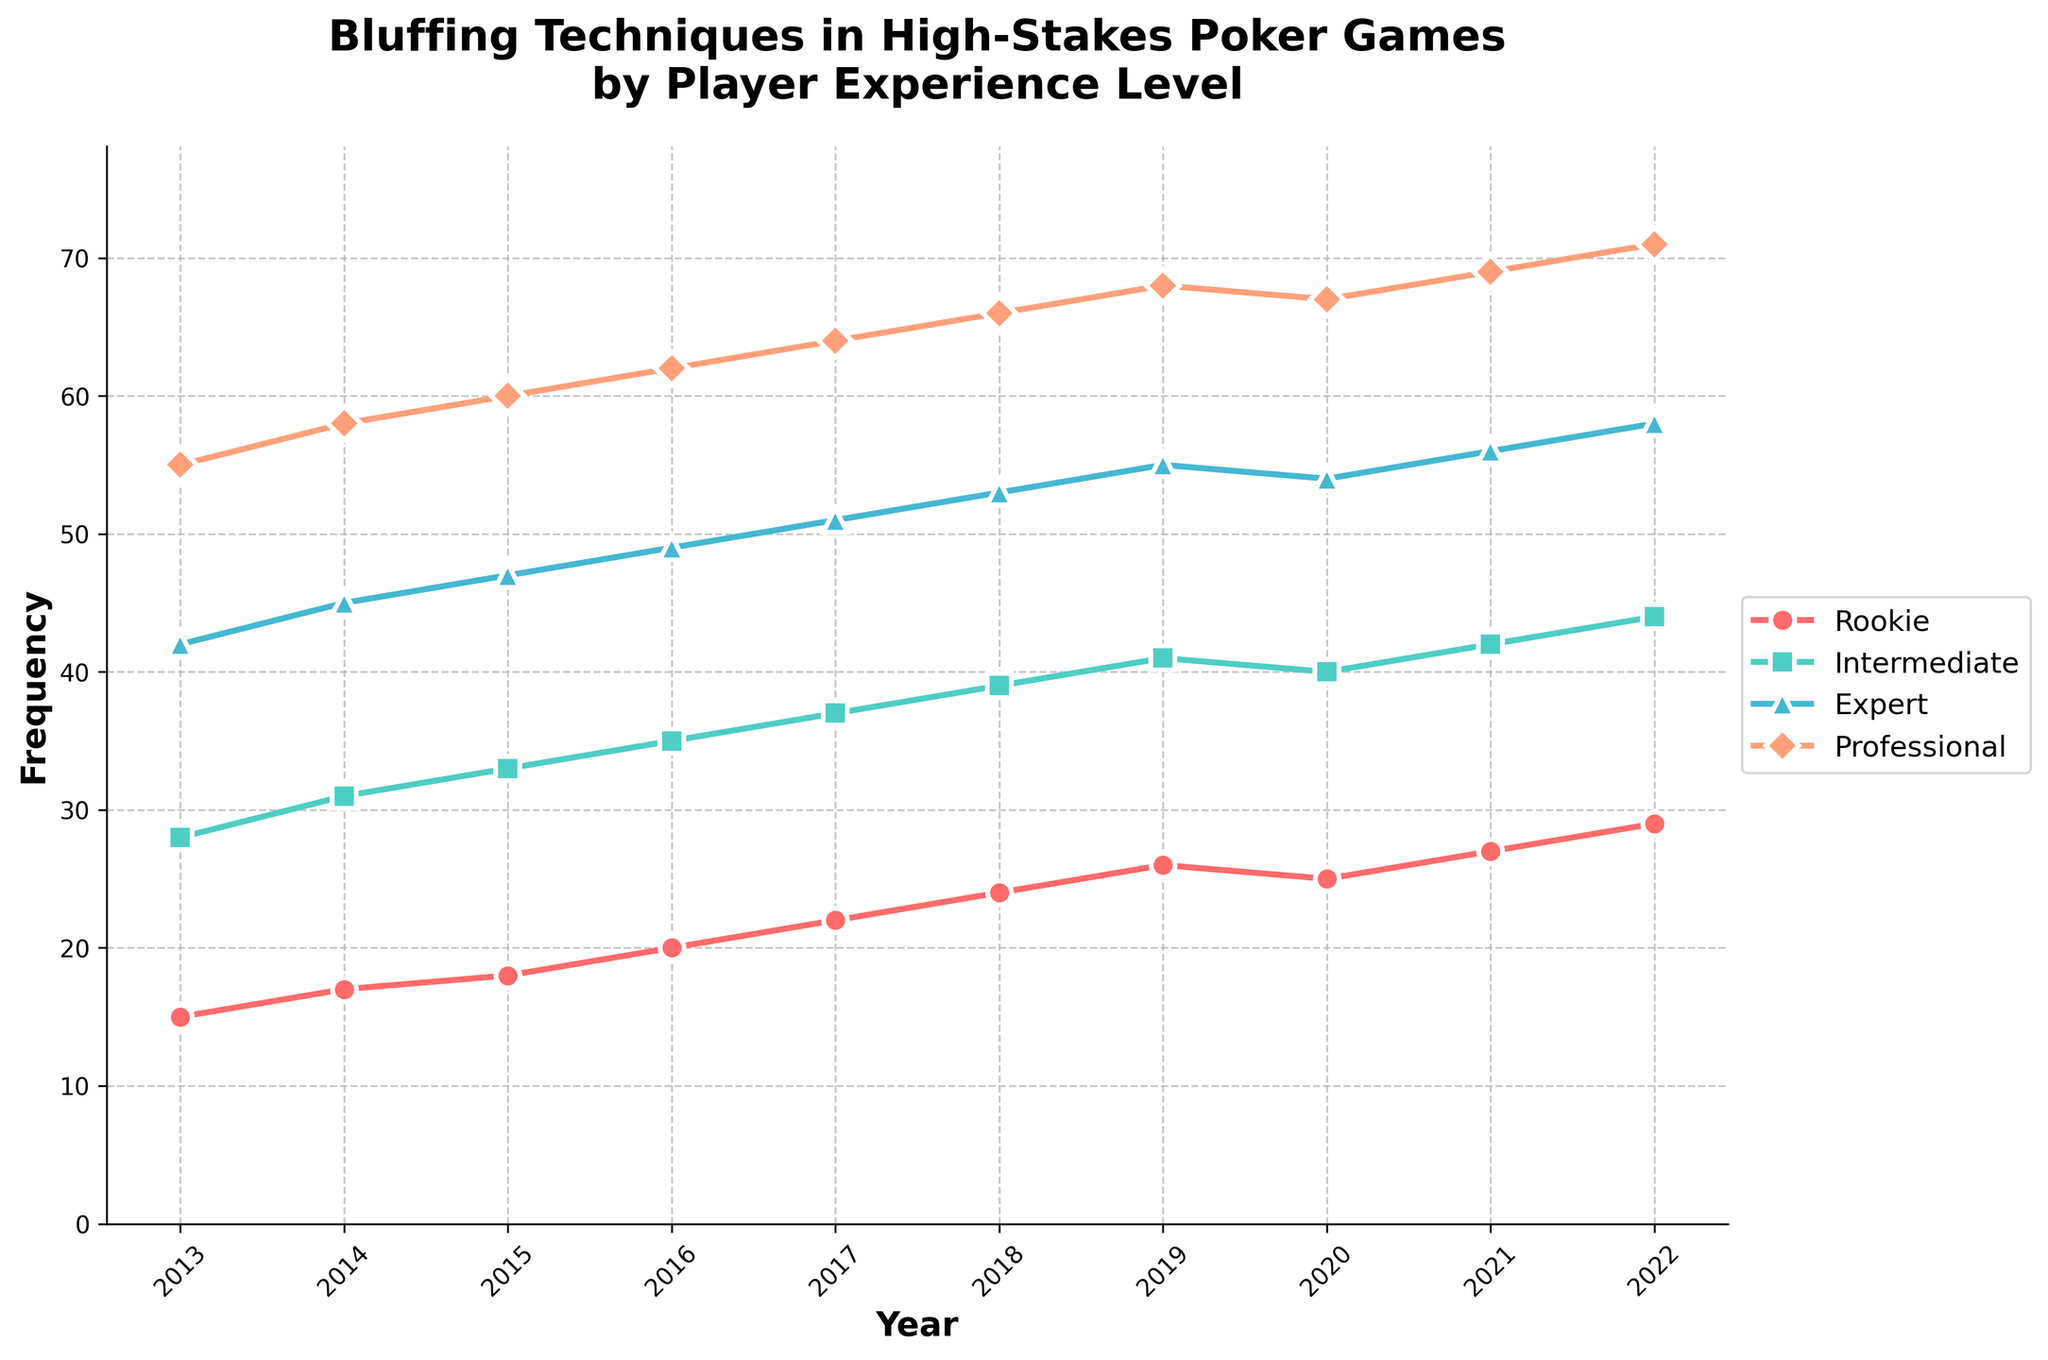Which player experience level had the highest frequency of bluffing techniques in 2015? By looking at the plot for 2015, identify the highest line among the categories. The Professional line is the highest.
Answer: Professional How did the frequency of bluffing techniques for Intermediate players change from 2013 to 2022? Find the value for Intermediate in 2013 and 2022, then calculate the difference: 44 (2022) - 28 (2013) = 16.
Answer: Increased by 16 In which year did Professional players have the largest frequency increment compared to the previous year? Compare the increments year by year: the largest increment is from 2021 to 2022 (2).
Answer: 2022 What's the difference between the frequency of bluffing techniques for Experts and Rookies in 2018? Find the value for Experts and Rookies in 2018, then subtract Rookie from Expert: 53 - 24 = 29.
Answer: 29 Which player experience level shows the most consistent growth in bluffing techniques from 2013 to 2022? Observing the lines, all show upward trends with slight variations mostly, but Professionals have the most consistent gradual increase.
Answer: Professional What trend is observed in the frequency of bluffing techniques for Rookie players in 2020 compared to other years? Unlike other years where there’s consistent growth, 2020 shows a slight decrease from 26 to 25 compared to 2019.
Answer: Decrease By how much did the frequency of bluffing techniques increase for Experts between 2013 and 2017? Find the value for Experts in 2013 (42) and 2017 (51), then calculate the difference: 51 - 42 = 9.
Answer: 9 What can you infer about the frequency of bluffing techniques used by Intermediate players between 2020 and 2021? Comparing the values for 2020 (40) and 2021 (42), there's a slight increase of 2.
Answer: Increased by 2 